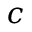<formula> <loc_0><loc_0><loc_500><loc_500>c</formula> 